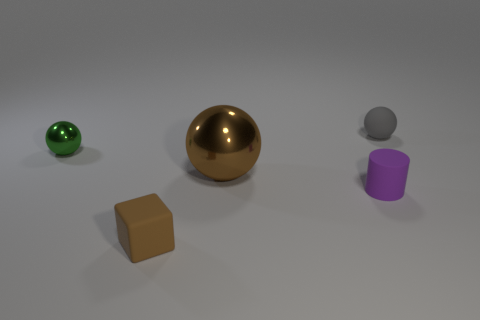What is the color of the metal sphere that is the same size as the gray rubber ball?
Make the answer very short. Green. There is a large metallic sphere; what number of small green balls are to the left of it?
Offer a very short reply. 1. Are any rubber balls visible?
Keep it short and to the point. Yes. There is a object that is behind the tiny thing that is left of the tiny rubber object to the left of the purple object; what is its size?
Provide a short and direct response. Small. How many other things are the same size as the brown cube?
Offer a terse response. 3. How big is the sphere behind the small metal sphere?
Offer a very short reply. Small. Are there any other things of the same color as the big thing?
Ensure brevity in your answer.  Yes. Are the brown object that is behind the cylinder and the cylinder made of the same material?
Provide a short and direct response. No. How many small things are behind the matte cylinder and in front of the tiny gray thing?
Provide a short and direct response. 1. What is the size of the metal sphere to the left of the shiny ball that is in front of the small green object?
Offer a terse response. Small. 